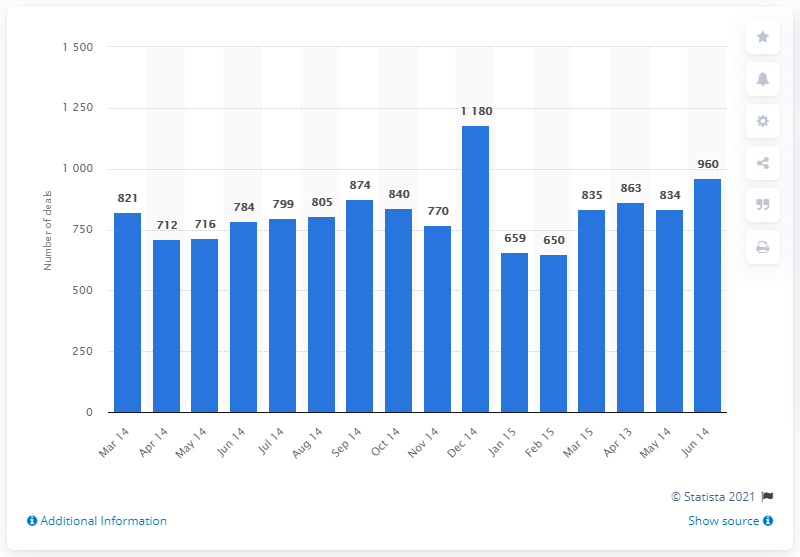Point out several critical features in this image. There were 960 mergers and acquisitions deals in Asia in June 2015. 